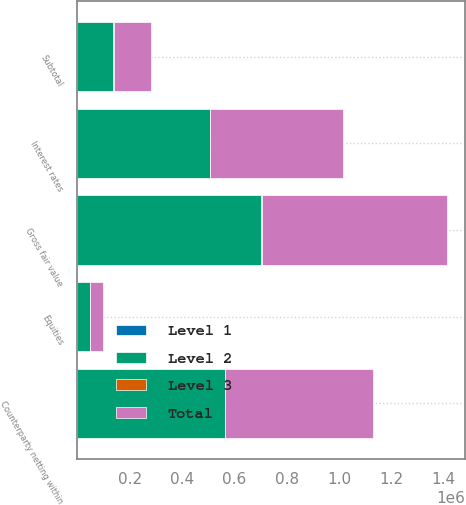<chart> <loc_0><loc_0><loc_500><loc_500><stacked_bar_chart><ecel><fcel>Interest rates<fcel>Equities<fcel>Gross fair value<fcel>Counterparty netting within<fcel>Subtotal<nl><fcel>Level 1<fcel>46<fcel>1<fcel>47<fcel>12<fcel>35<nl><fcel>Level 2<fcel>506818<fcel>47667<fcel>699585<fcel>564100<fcel>135485<nl><fcel>Level 3<fcel>614<fcel>424<fcel>6607<fcel>1417<fcel>5190<nl><fcel>Total<fcel>507478<fcel>48092<fcel>706239<fcel>565529<fcel>140710<nl></chart> 